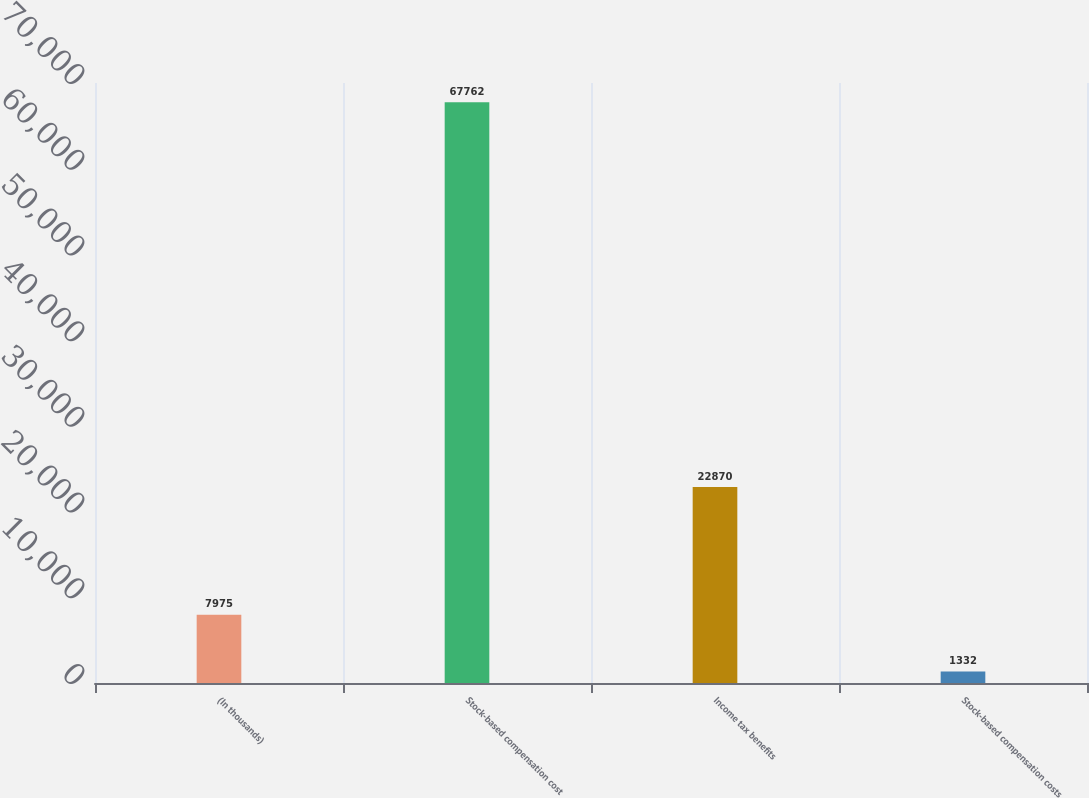<chart> <loc_0><loc_0><loc_500><loc_500><bar_chart><fcel>(In thousands)<fcel>Stock-based compensation cost<fcel>Income tax benefits<fcel>Stock-based compensation costs<nl><fcel>7975<fcel>67762<fcel>22870<fcel>1332<nl></chart> 